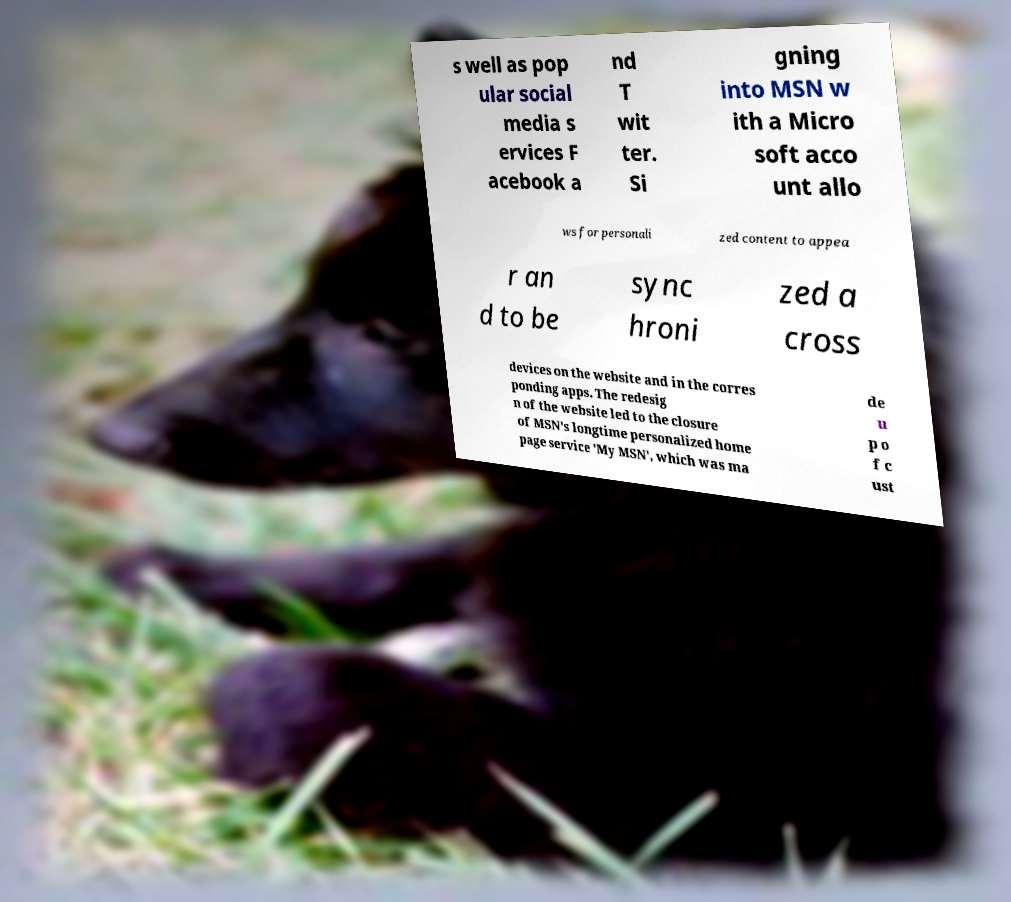Please read and relay the text visible in this image. What does it say? s well as pop ular social media s ervices F acebook a nd T wit ter. Si gning into MSN w ith a Micro soft acco unt allo ws for personali zed content to appea r an d to be sync hroni zed a cross devices on the website and in the corres ponding apps. The redesig n of the website led to the closure of MSN's longtime personalized home page service 'My MSN', which was ma de u p o f c ust 